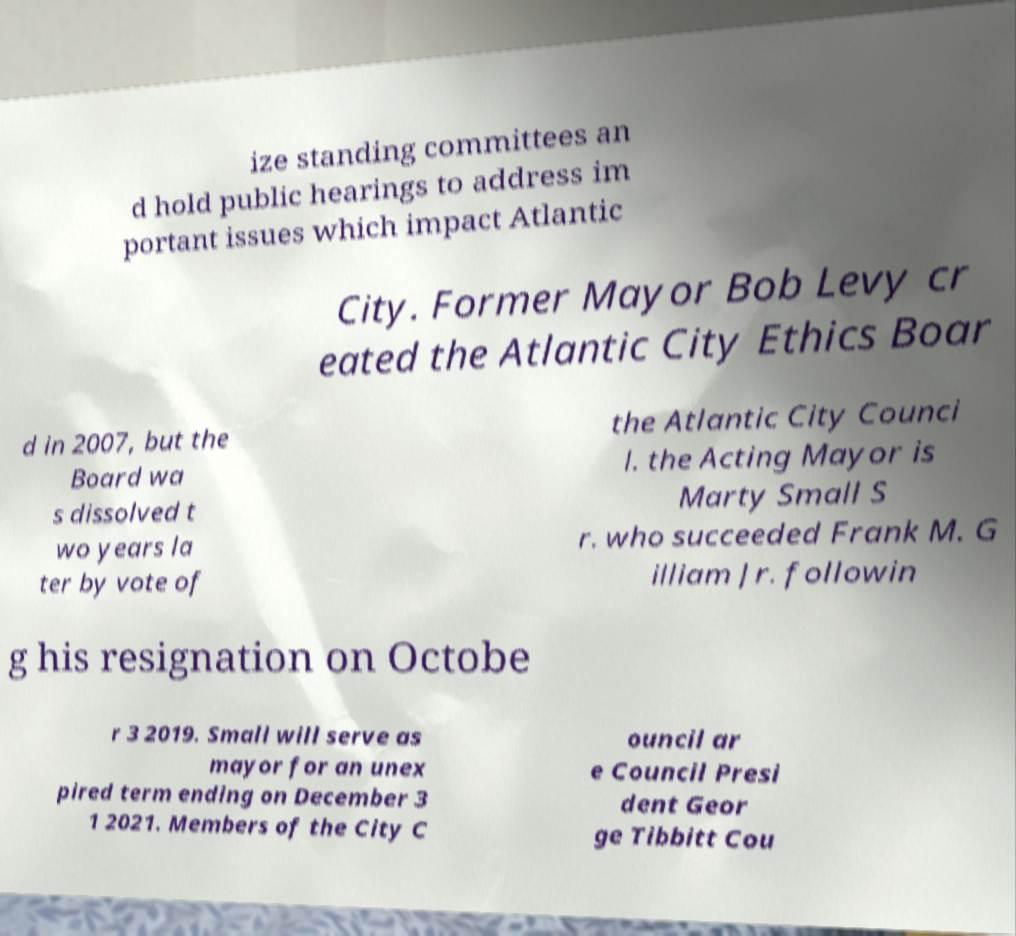There's text embedded in this image that I need extracted. Can you transcribe it verbatim? ize standing committees an d hold public hearings to address im portant issues which impact Atlantic City. Former Mayor Bob Levy cr eated the Atlantic City Ethics Boar d in 2007, but the Board wa s dissolved t wo years la ter by vote of the Atlantic City Counci l. the Acting Mayor is Marty Small S r. who succeeded Frank M. G illiam Jr. followin g his resignation on Octobe r 3 2019. Small will serve as mayor for an unex pired term ending on December 3 1 2021. Members of the City C ouncil ar e Council Presi dent Geor ge Tibbitt Cou 